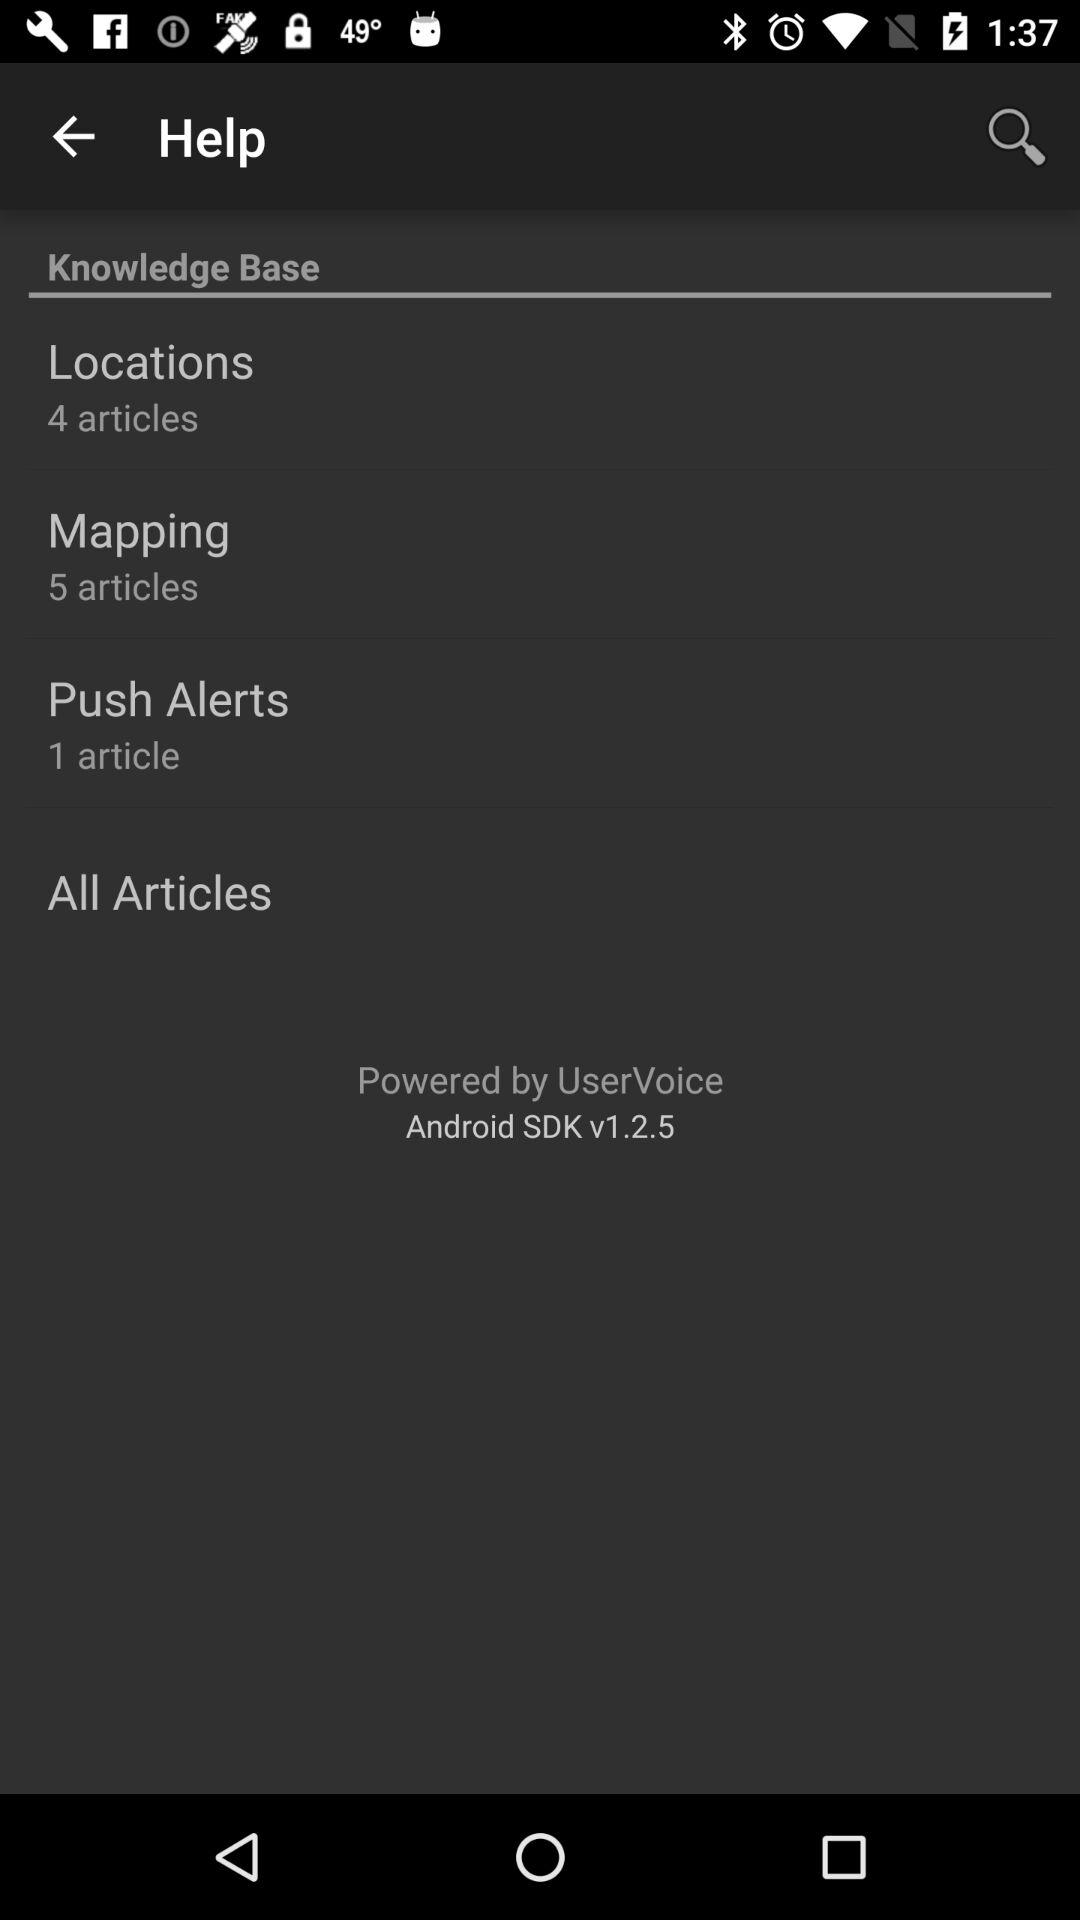How many articles are in the Push Alerts section? 1 